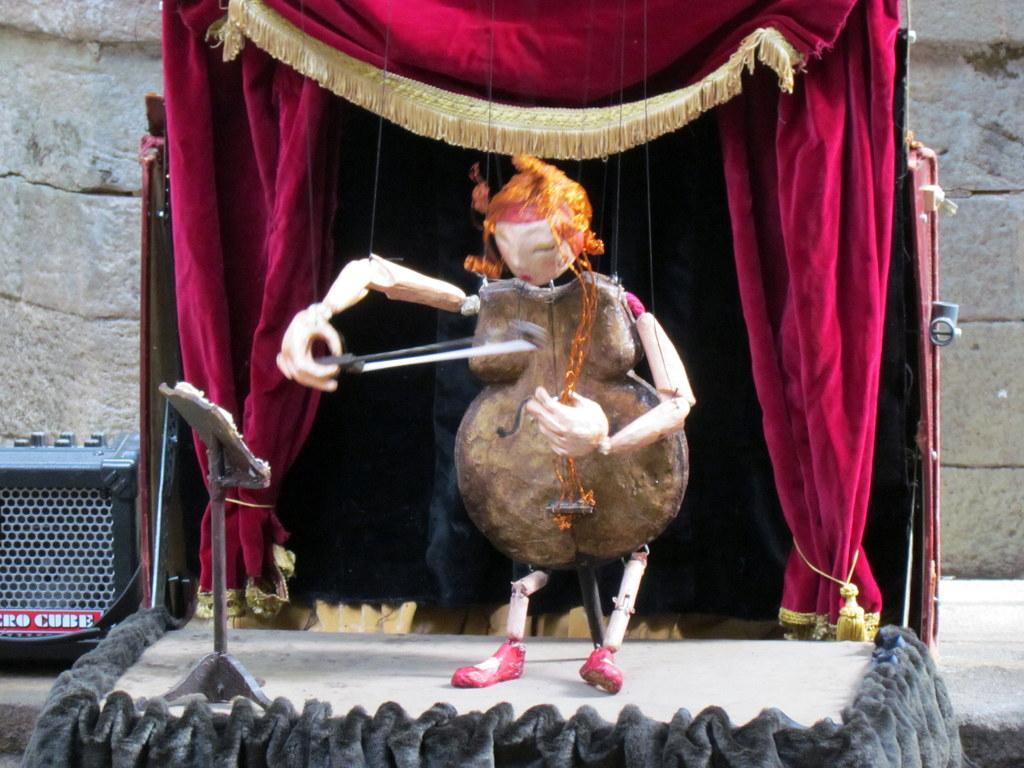Could you give a brief overview of what you see in this image? In this image there is a toy playing an musical instrument, beside the toy there is a stand, behind the toy there are curtains and on the left side of the image there is a speaker. In the background there is a wall. 